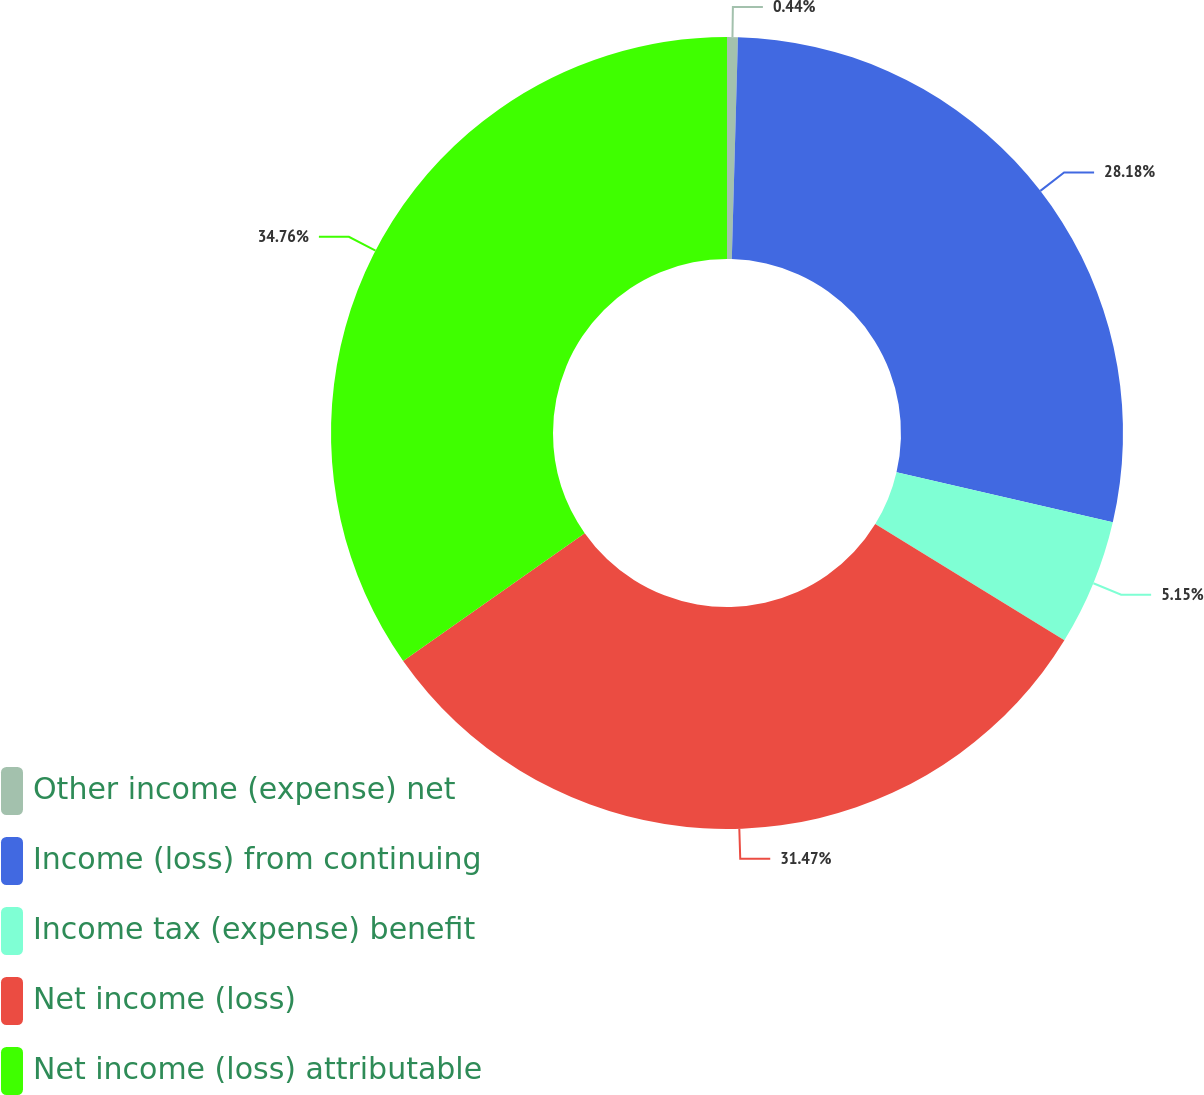Convert chart to OTSL. <chart><loc_0><loc_0><loc_500><loc_500><pie_chart><fcel>Other income (expense) net<fcel>Income (loss) from continuing<fcel>Income tax (expense) benefit<fcel>Net income (loss)<fcel>Net income (loss) attributable<nl><fcel>0.44%<fcel>28.18%<fcel>5.15%<fcel>31.47%<fcel>34.76%<nl></chart> 